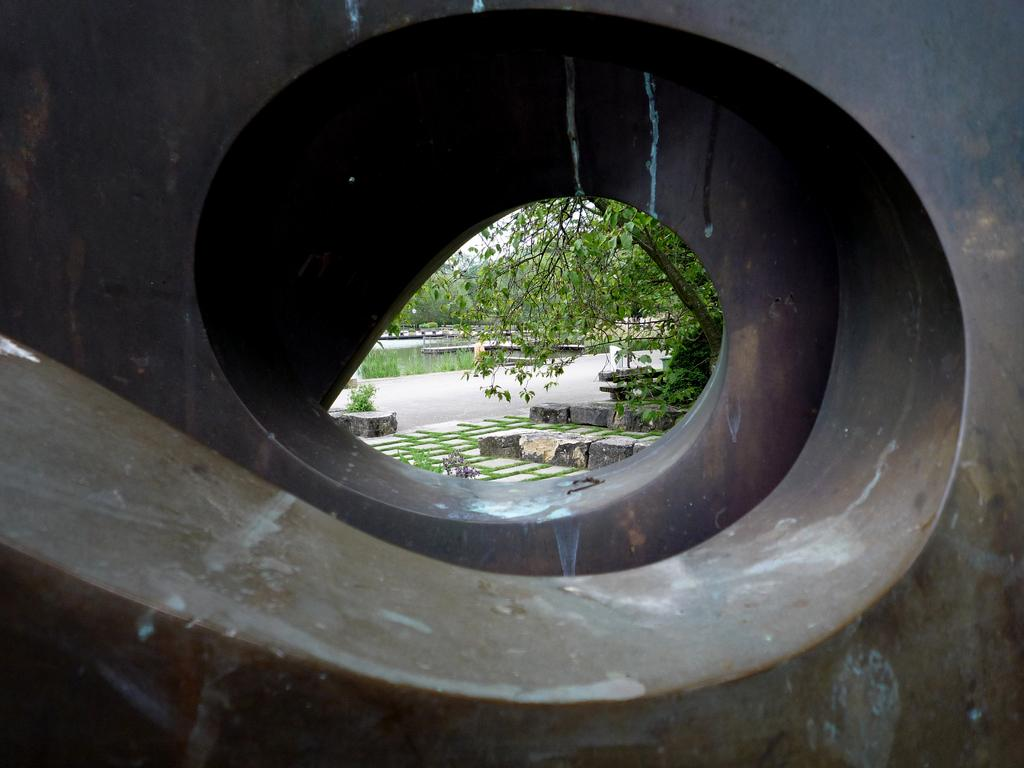What type of structure is present in the image? There is a metal pipeline in the image. What type of vegetation can be seen in the image? There are plants, grass, and trees in the image. What part of the natural environment is visible in the image? The sky is visible in the image. What type of advice can be seen written on the pipeline in the image? There is no advice written on the pipeline in the image; it is a metal structure for transporting substances. 